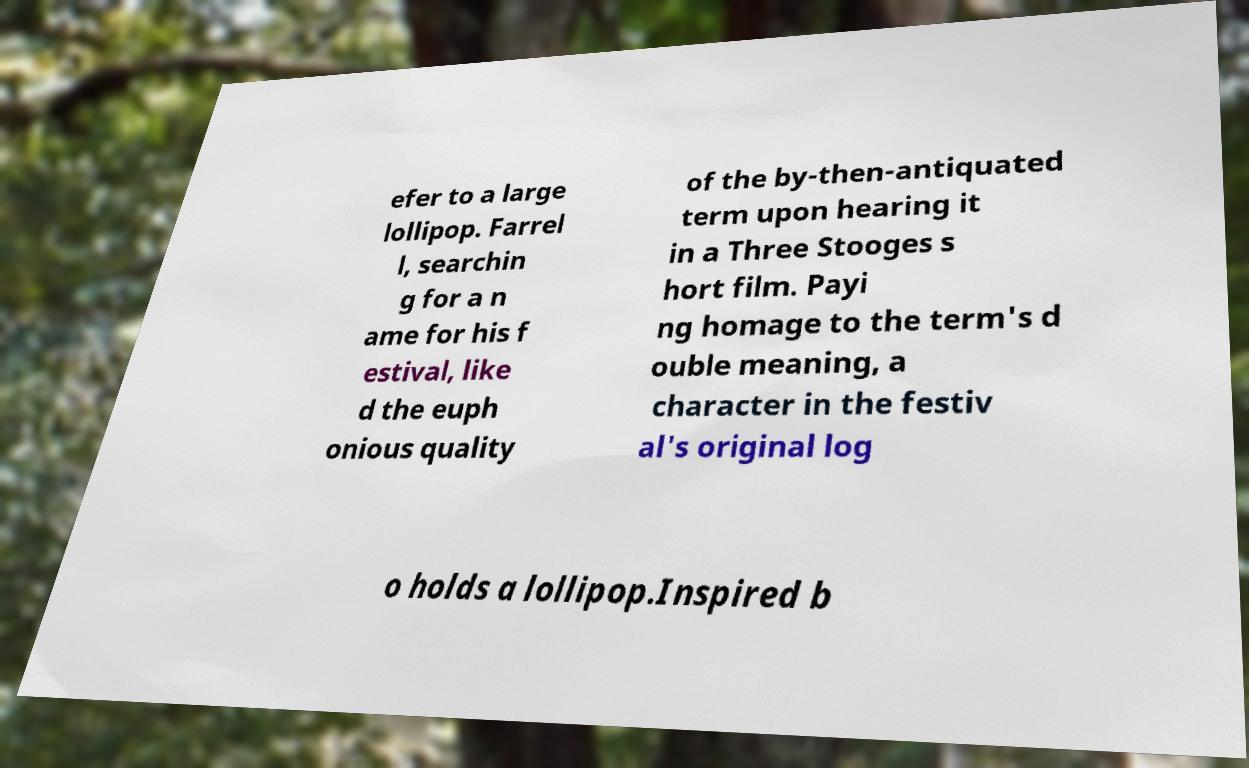Could you extract and type out the text from this image? efer to a large lollipop. Farrel l, searchin g for a n ame for his f estival, like d the euph onious quality of the by-then-antiquated term upon hearing it in a Three Stooges s hort film. Payi ng homage to the term's d ouble meaning, a character in the festiv al's original log o holds a lollipop.Inspired b 